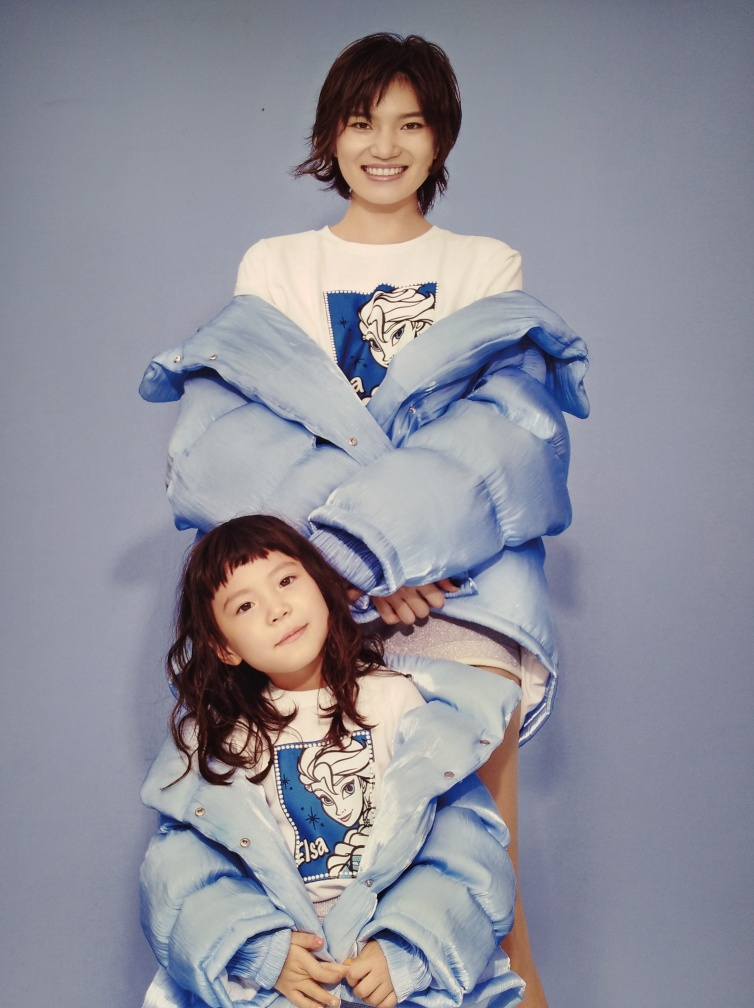What might be the significance of the printed characters on their shirts? The characters printed on their shirts appear to be from popular media, which often serve as a form of personal expression or shared interest. It could suggest their admiration for the characters or the themes represented, and also provides a visual link between the two individuals, further emphasizing the connection between them. How does the lighting affect the mood of this image? The soft, even lighting in the image creates a gentle ambiance without harsh shadows, which complements the subjects' cheerful demeanor. It accentuates the subjects' features and contributes to the overall inviting and positive mood of the photograph. 